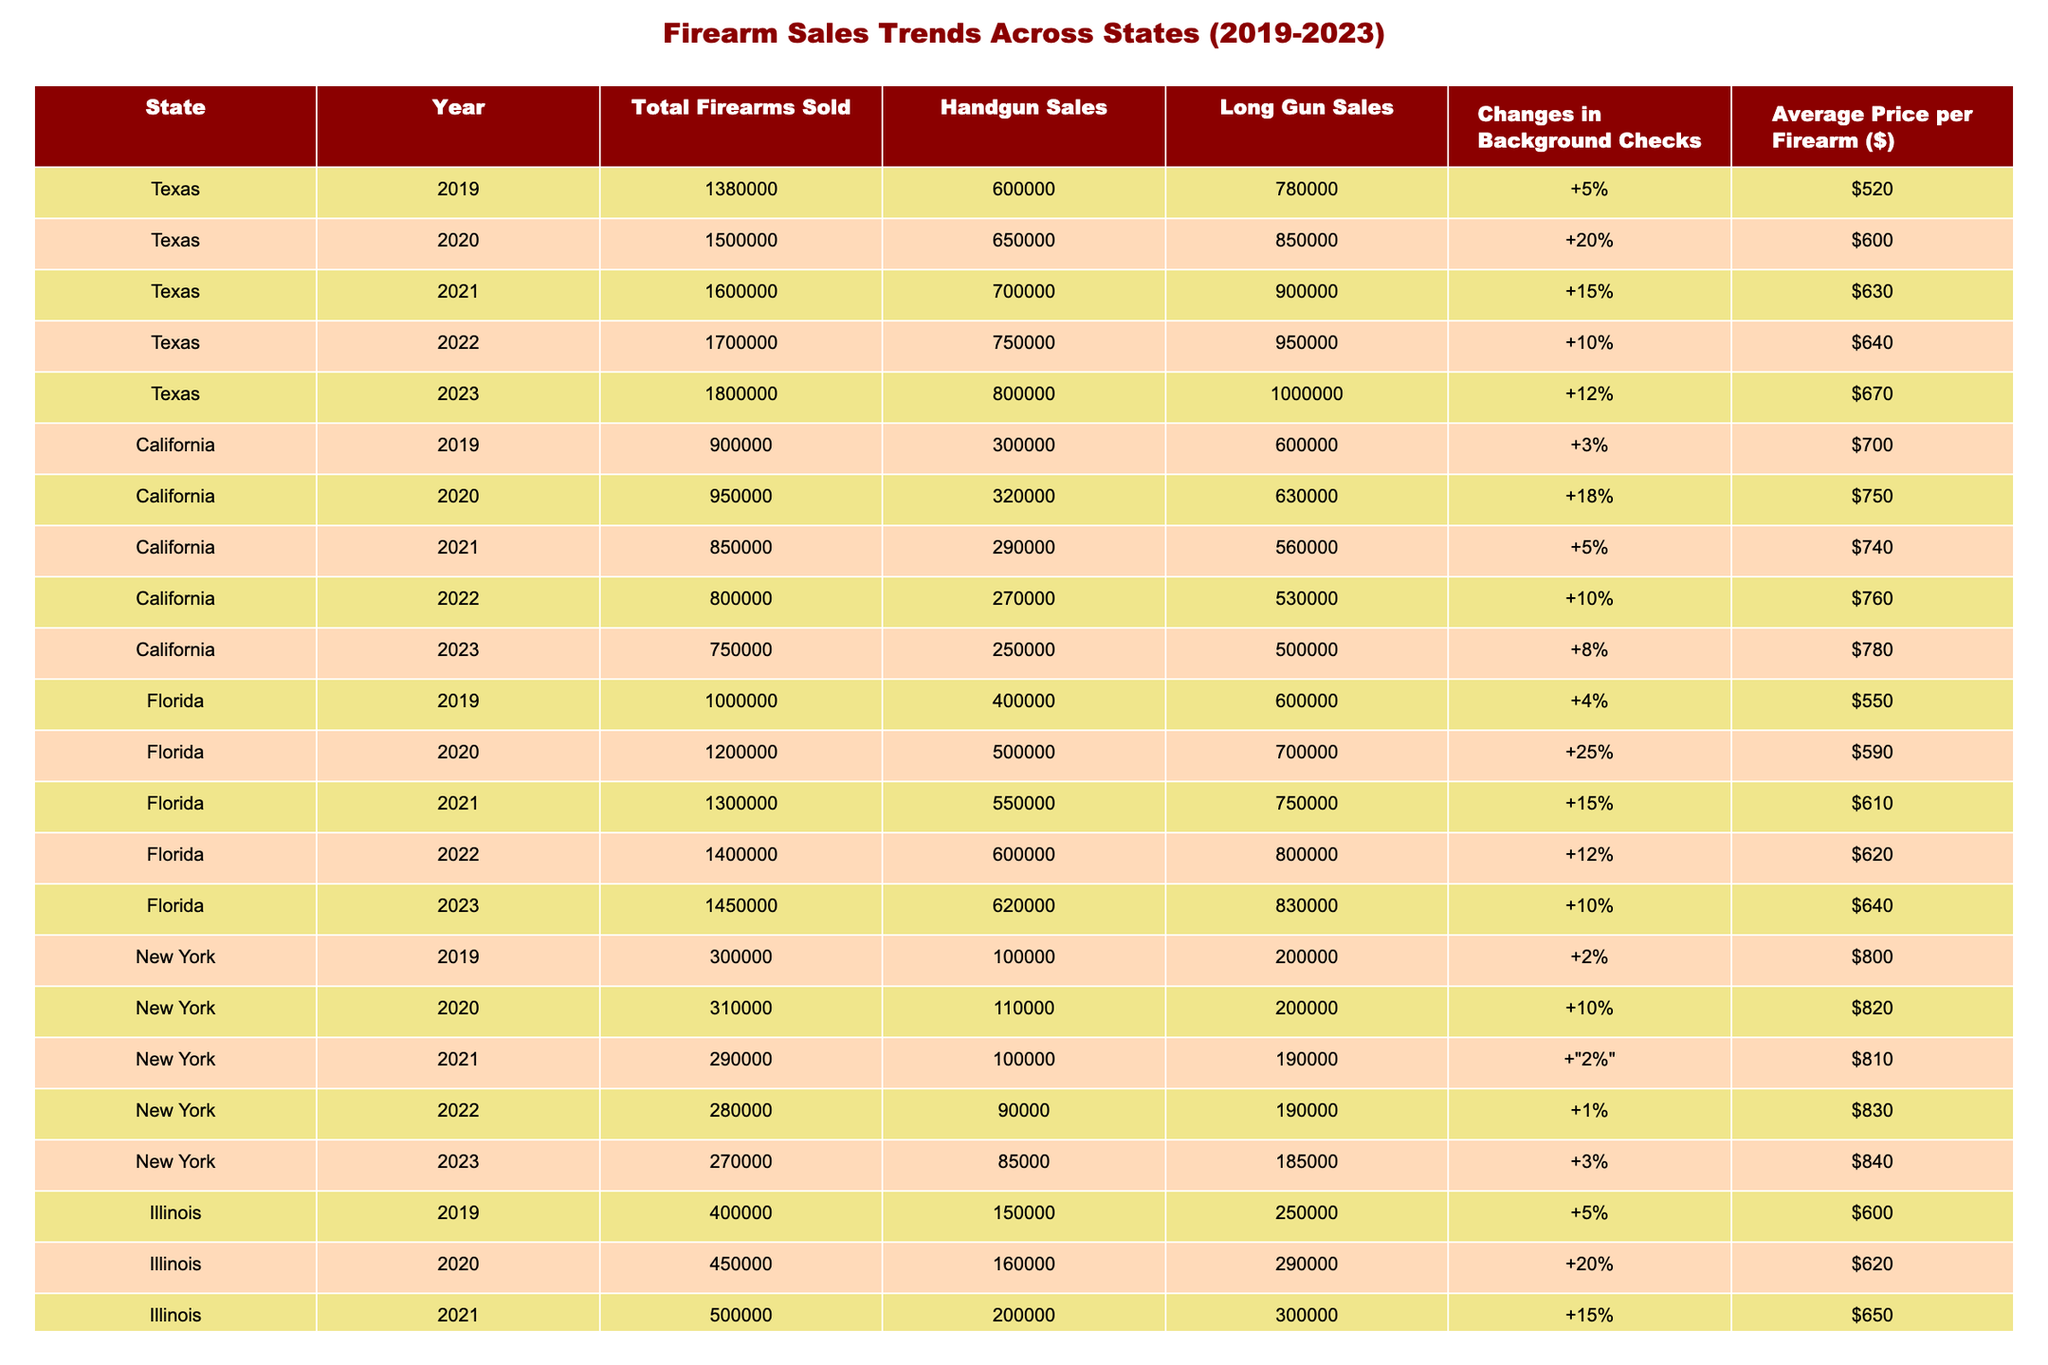What was the total number of firearms sold in Texas in 2022? In the row for Texas in the year 2022, the value for Total Firearms Sold is listed as 1,700,000.
Answer: 1,700,000 Which state had the highest handgun sales in 2021? Looking at the Handgun Sales column for 2021, Texas had 700,000 sales while Florida had 550,000, California had 290,000, New York had 100,000, and Illinois had 200,000. Texas has the highest value.
Answer: Texas What is the percentage change in background checks in Florida from 2019 to 2023? The background checks changed from +4% in 2019 to +10% in 2023. To find the difference, we subtract: 10% - 4% = 6%.
Answer: 6% In which year did California see the highest total firearms sold? Reviewing the Total Firearms Sold column for California over the years, the values are 900,000 (2019), 950,000 (2020), 850,000 (2021), 800,000 (2022), and 750,000 (2023). The highest value is in 2020 with 950,000.
Answer: 2020 Is it true that Illinois had more total firearms sold in 2021 than in 2020? In 2021, Illinois had 500,000 firearms sold, while in 2020, it sold 450,000. 500,000 is greater than 450,000, so this statement is true.
Answer: Yes What was the average price per firearm in New York in 2020 compared to 2023? In 2020, the average price per firearm in New York was $820, and in 2023 it is $840. The comparison shows that the price increased by $20.
Answer: $820 vs $840 What is the sum of all long gun sales in Florida over the last 5 years? The long gun sales for Florida from 2019 to 2023 are 600,000 (2019), 700,000 (2020), 750,000 (2021), 800,000 (2022), and 830,000 (2023). Summing these values gives: 600,000 + 700,000 + 750,000 + 800,000 + 830,000 = 2,880,000.
Answer: 2,880,000 Which state had the largest increase in total firearms sold from 2019 to 2023? Analyzing the Total Firearms Sold for Texas, it went from 1,380,000 in 2019 to 1,800,000 in 2023 for an increase of 420,000. For Florida, the increase is 450,000, California decreases, New York decreases, and Illinois increases by 180,000. Florida had the largest increase.
Answer: Florida 